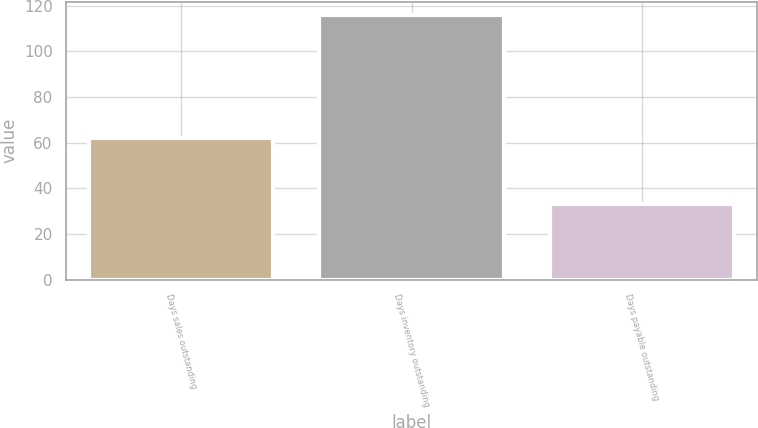Convert chart to OTSL. <chart><loc_0><loc_0><loc_500><loc_500><bar_chart><fcel>Days sales outstanding<fcel>Days inventory outstanding<fcel>Days payable outstanding<nl><fcel>62<fcel>116<fcel>33<nl></chart> 